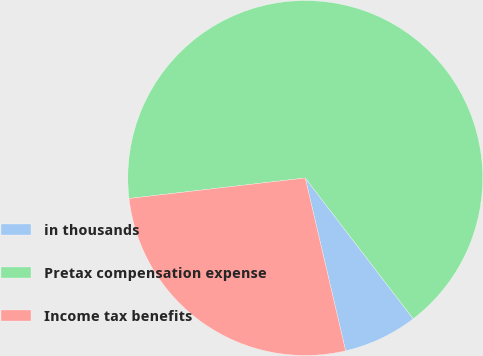<chart> <loc_0><loc_0><loc_500><loc_500><pie_chart><fcel>in thousands<fcel>Pretax compensation expense<fcel>Income tax benefits<nl><fcel>6.76%<fcel>66.43%<fcel>26.81%<nl></chart> 